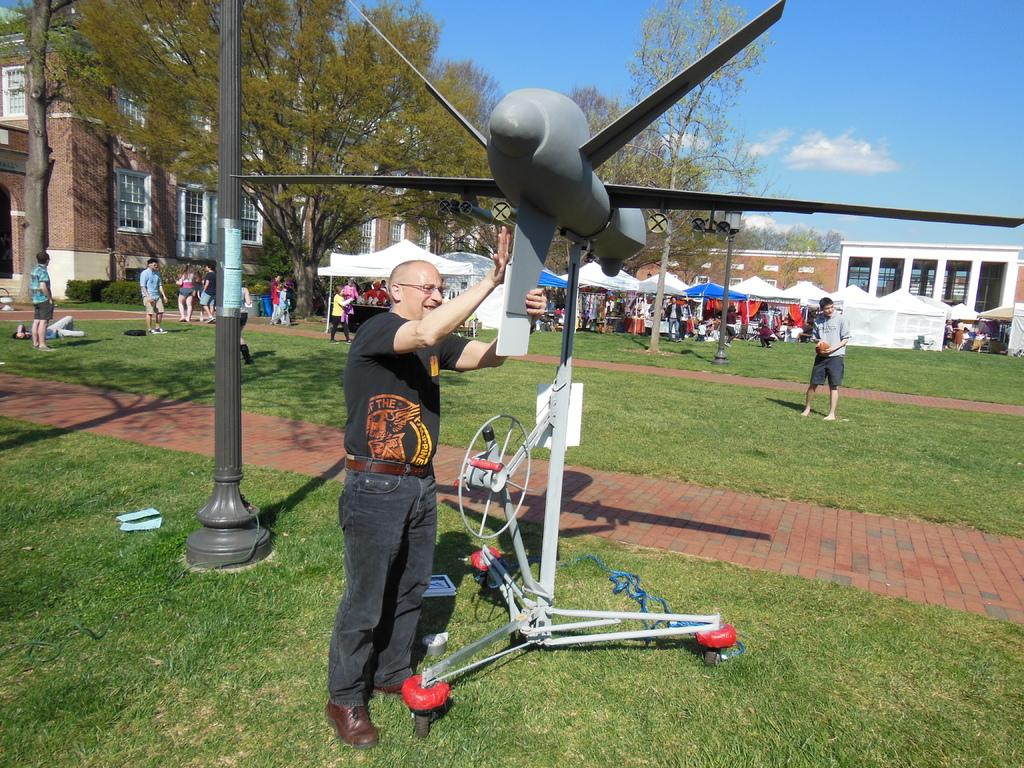What is the person in the image holding? The person is holding a demo airplane. What can be seen in the image besides the person? There are stalls, buildings, trees, a group of people, and the sky visible in the image. What might the stalls be selling or showcasing? It is not specified in the facts, but they could be selling or showcasing various items or services. How many people are present in the image? There is one person holding a demo airplane, and there is a group of people, so there are at least two people in the image. What type of muscle can be seen flexing in the image? There is no muscle flexing visible in the image. How many tickets are being sold at the stalls in the image? The facts do not mention tickets or stalls selling anything, so it is not possible to determine the number of tickets being sold. 